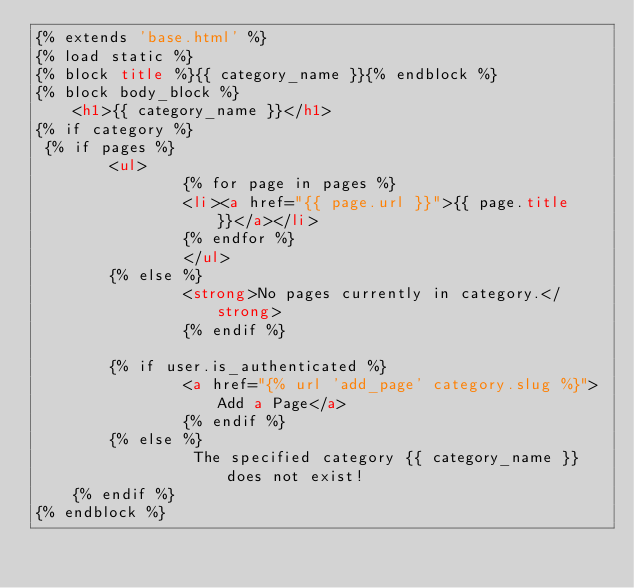Convert code to text. <code><loc_0><loc_0><loc_500><loc_500><_HTML_>{% extends 'base.html' %}
{% load static %}
{% block title %}{{ category_name }}{% endblock %}
{% block body_block %}
    <h1>{{ category_name }}</h1>
{% if category %}
 {% if pages %}
        <ul>
                {% for page in pages %}
                <li><a href="{{ page.url }}">{{ page.title }}</a></li>
                {% endfor %}
                </ul>
        {% else %}
                <strong>No pages currently in category.</strong>
                {% endif %}

        {% if user.is_authenticated %}
                <a href="{% url 'add_page' category.slug %}">Add a Page</a>
                {% endif %}
        {% else %}
                 The specified category {{ category_name }} does not exist!
    {% endif %}
{% endblock %}
</code> 